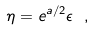<formula> <loc_0><loc_0><loc_500><loc_500>\eta = e ^ { a / 2 } \epsilon \ ,</formula> 